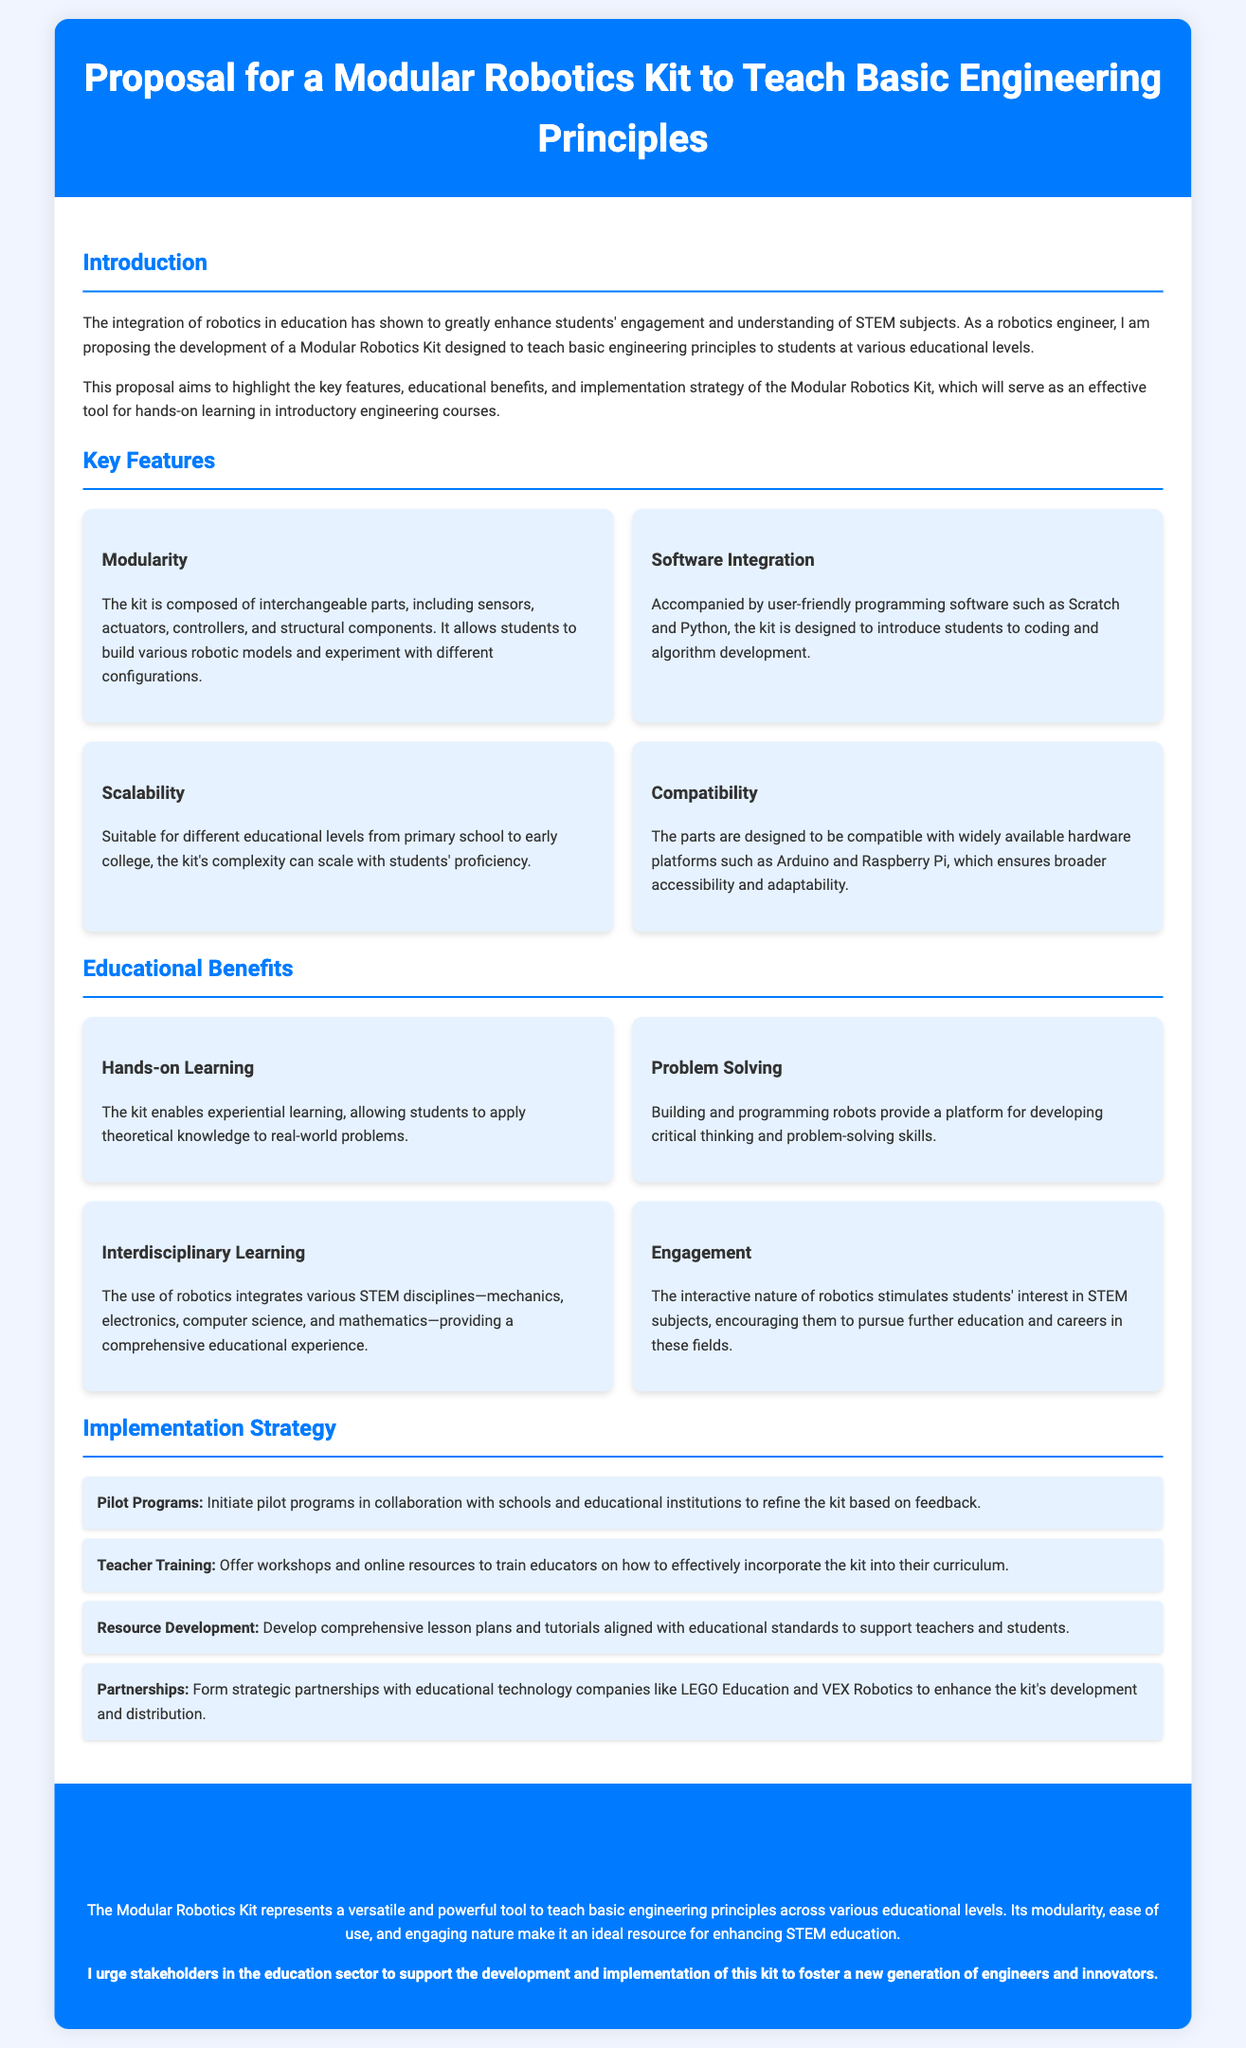What is the title of the proposal? The title of the proposal is presented in the header section of the document.
Answer: Proposal for a Modular Robotics Kit to Teach Basic Engineering Principles What types of programming software are included in the kit? The software integration section lists the specific programming software that accompanies the kit.
Answer: Scratch and Python What is the main purpose of the Modular Robotics Kit? The introduction section describes the intended goal of the robotics kit.
Answer: To teach basic engineering principles What is one of the key features related to the adaptability of the kit? The kit's feature of scalability mentioned in the document illustrates its adaptability.
Answer: Scalability Which educational technology companies are mentioned for partnerships? The implementation strategy highlights potential partnerships for enhancing the kit.
Answer: LEGO Education and VEX Robotics What benefit does experiential learning provide according to the document? The educational benefits section explains the importance of hands-on learning.
Answer: It enables experiential learning How many items are listed under Implementation Strategy? The implementation strategy section includes a list of distinct actions that can be counted.
Answer: Four What framework is the kit designed to support? The resource development section indicates alignment with specific frameworks for teaching.
Answer: Educational standards 